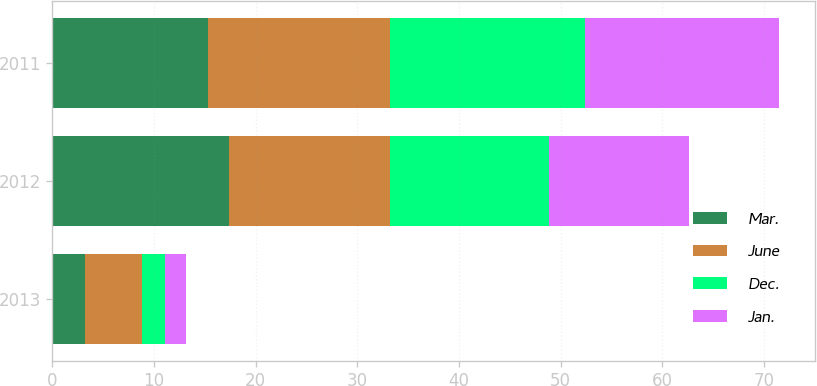Convert chart to OTSL. <chart><loc_0><loc_0><loc_500><loc_500><stacked_bar_chart><ecel><fcel>2013<fcel>2012<fcel>2011<nl><fcel>Mar.<fcel>3.2<fcel>17.4<fcel>15.3<nl><fcel>June<fcel>5.6<fcel>15.8<fcel>17.9<nl><fcel>Dec.<fcel>2.3<fcel>15.7<fcel>19.2<nl><fcel>Jan.<fcel>2<fcel>13.7<fcel>19.1<nl></chart> 